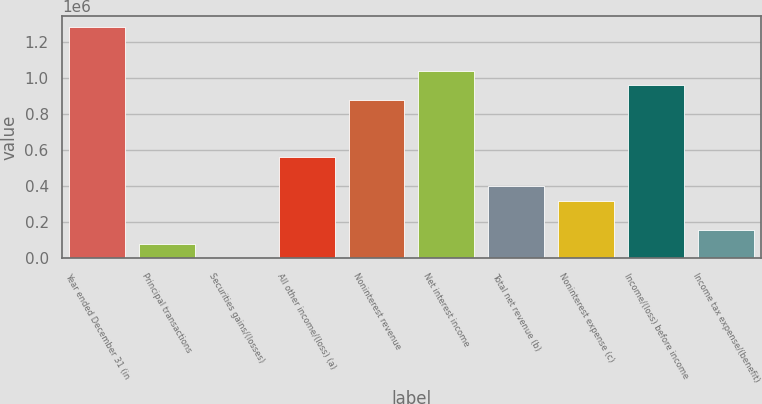Convert chart to OTSL. <chart><loc_0><loc_0><loc_500><loc_500><bar_chart><fcel>Year ended December 31 (in<fcel>Principal transactions<fcel>Securities gains/(losses)<fcel>All other income/(loss) (a)<fcel>Noninterest revenue<fcel>Net interest income<fcel>Total net revenue (b)<fcel>Noninterest expense (c)<fcel>Income/(loss) before income<fcel>Income tax expense/(benefit)<nl><fcel>1.279e+06<fcel>80068.6<fcel>140<fcel>559640<fcel>879355<fcel>1.03921e+06<fcel>399783<fcel>319854<fcel>959283<fcel>159997<nl></chart> 